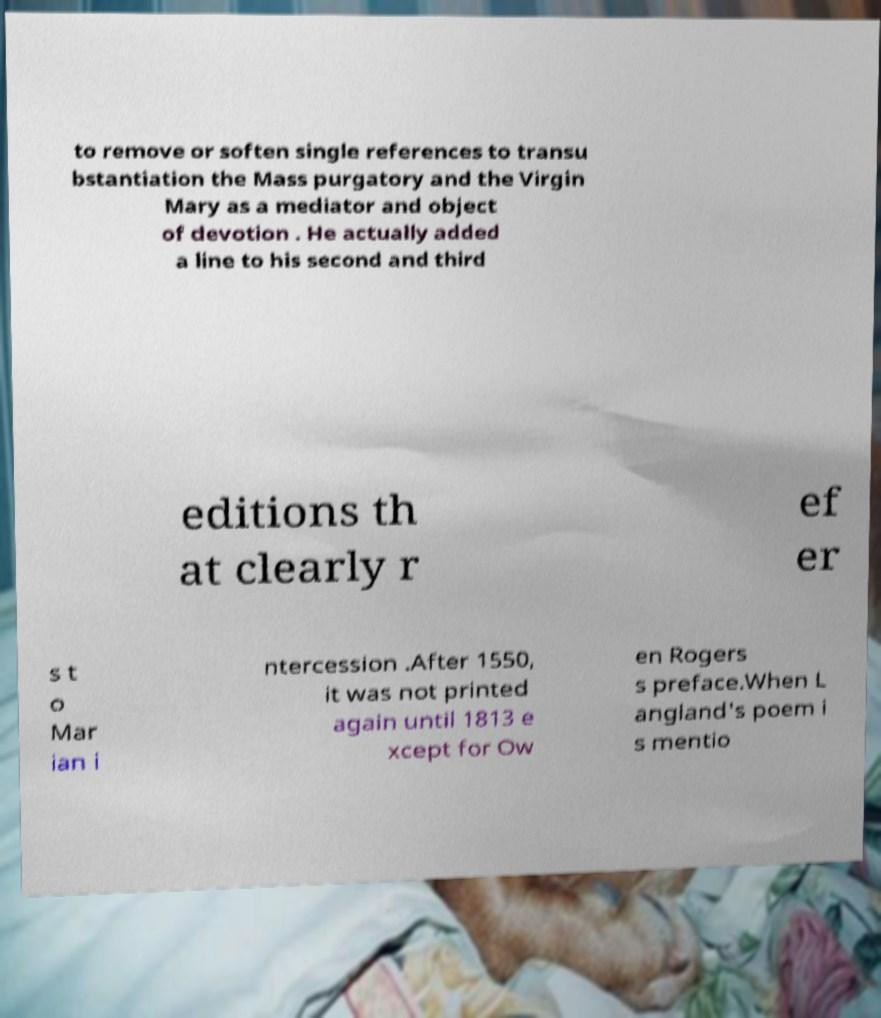Can you read and provide the text displayed in the image?This photo seems to have some interesting text. Can you extract and type it out for me? to remove or soften single references to transu bstantiation the Mass purgatory and the Virgin Mary as a mediator and object of devotion . He actually added a line to his second and third editions th at clearly r ef er s t o Mar ian i ntercession .After 1550, it was not printed again until 1813 e xcept for Ow en Rogers s preface.When L angland's poem i s mentio 